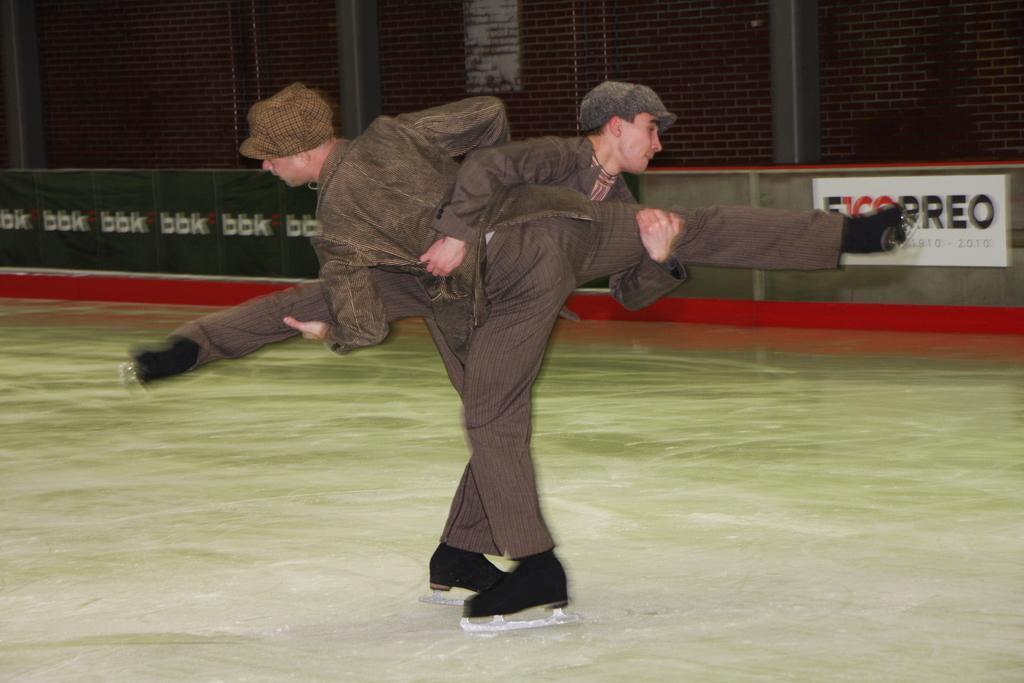In one or two sentences, can you explain what this image depicts? In the center of the we can see two people holding each other and skating on the ice. In the background there is a board and a wall. 